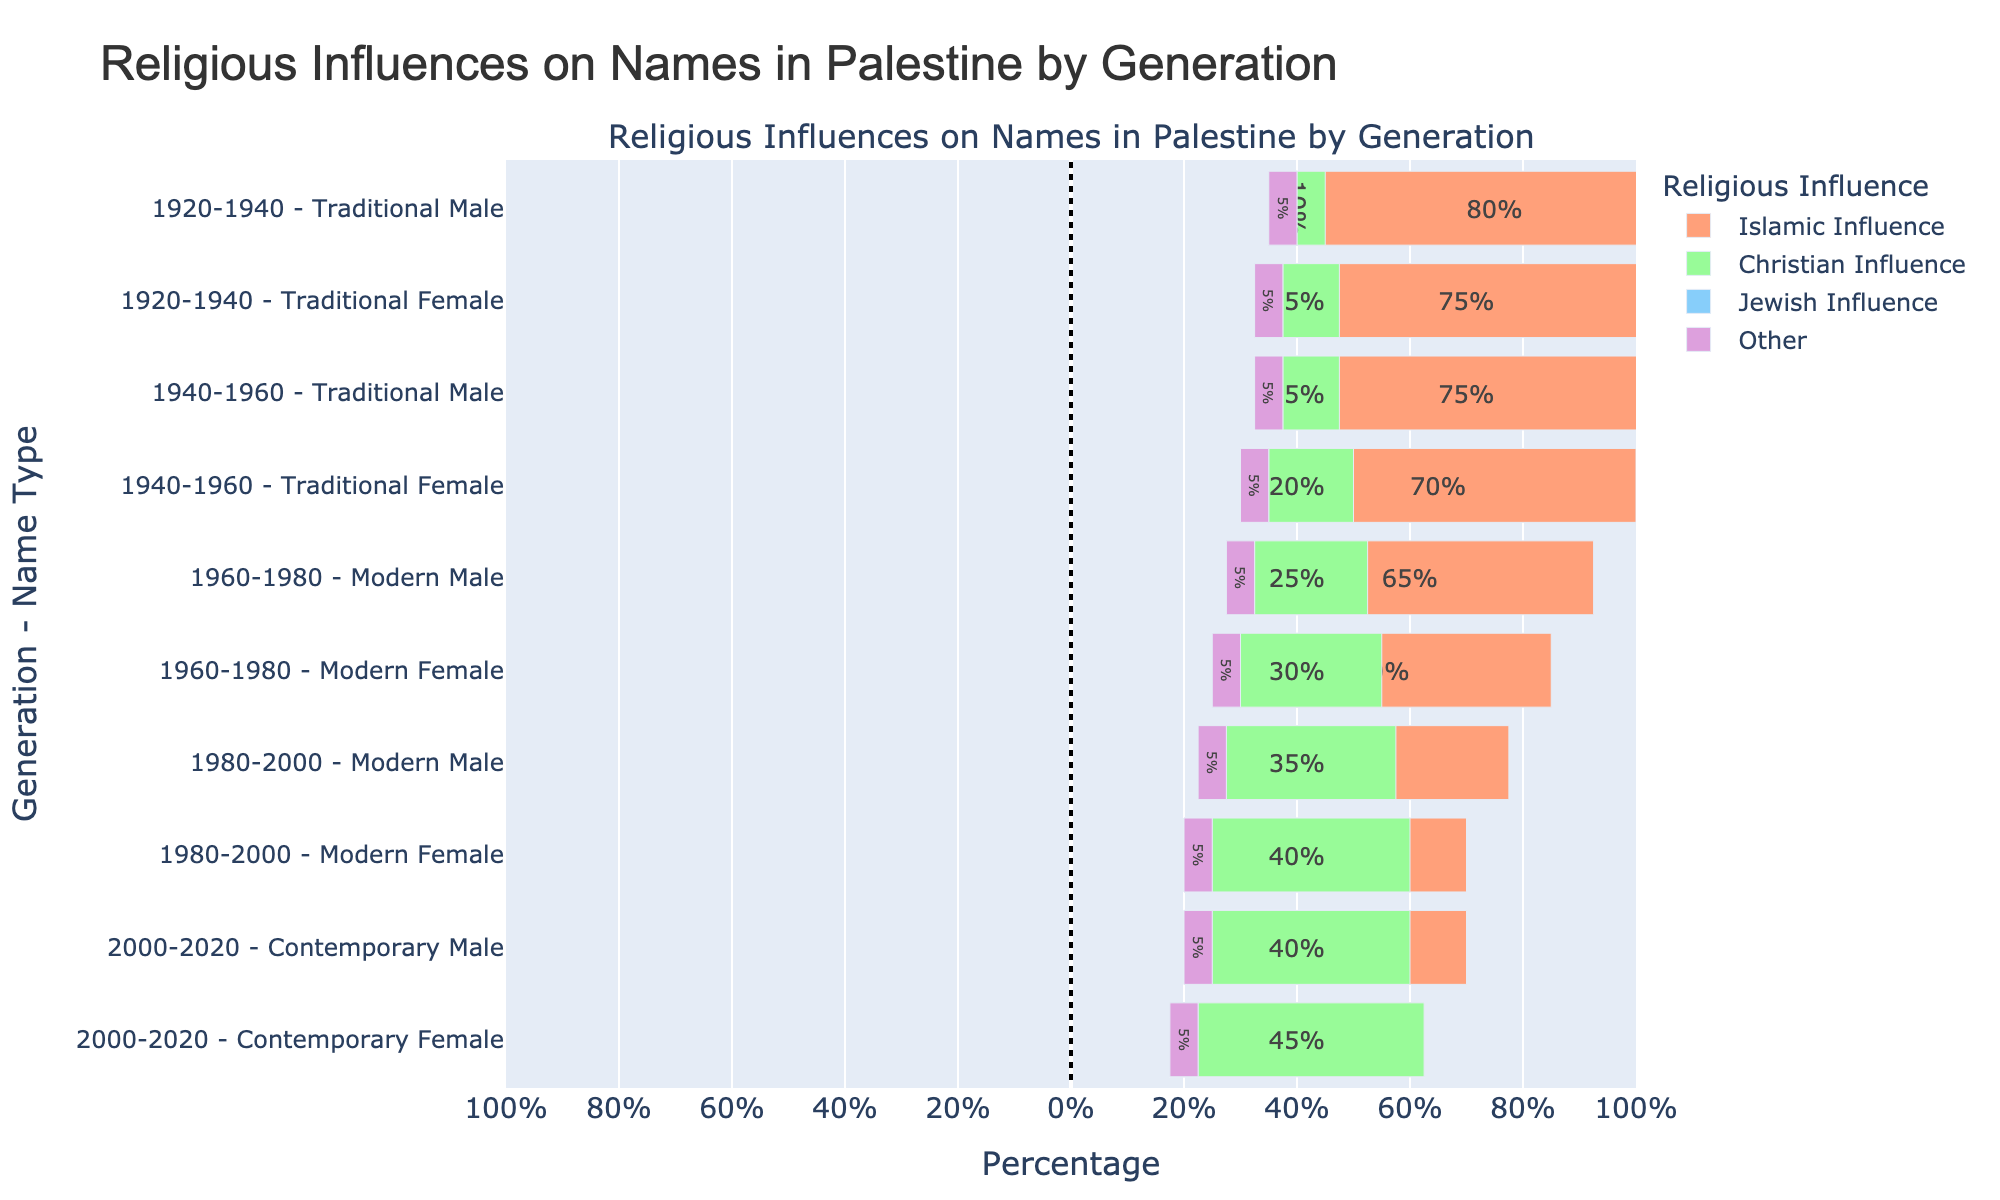What generation has the highest percentage of names with Christian influence? The highest percentage of Christian influence corresponds to the earliest generation, which can be identified from the y-axis and the corresponding bars. For 1920-1940, the Traditional Female names have 15% Christian influence, which decreases in subsequent generations except for a noticeable increase across time.
Answer: 2000-2020 How does the Islamic influence on Contemporary Female names compare to Traditional Male names from 1940-1960? The Islamic influence for Contemporary Female names from 2000-2020 is 45%, while for Traditional Male names from 1940-1960, it's 75%. The comparison shows a decrease over time.
Answer: Decreased Which gender saw a greater reduction in Islamic influence from 1920-2020? To answer this, we compare the Islamic influence on Traditional Male and Traditional Female names in 1920-1940 with that of Contemporary Male and Contemporary Female names in 2000-2020. Traditional Male names started at 80%, reducing to 50%, a decrease of 30%. Traditional Female names started at 75%, decreasing to 45%, a reduction of 30%. Since both reductions are equal, neither saw a greater decrease.
Answer: Equal What is the total percentage of non-Islamic influences (sum of Christian, Jewish, and Other) on Modern Male names in 1960-1980? The percentages of Christian, Jewish, and Other influences on Modern Male names in this generation are 25%, 5%, and 5% respectively. Summing these percentages: 25 + 5 + 5 = 35%.
Answer: 35% Which generation and name type have the least percentage of Jewish influence? By examining the Jewish influence across each generation and name type, we see that the percentage remains constant at 5% across all categories. Hence, no specific generation or name type can be singled out.
Answer: All equal What is the difference in Christian influence between Modern Female and Contemporary Female names? The Christian influence on Modern Female names (1960-1980) is 30%, while for Contemporary Female names (2000-2020) it is 45%. The difference is calculated as 45 - 30 = 15%.
Answer: 15% Which generation of male names displays the most balanced distribution of influences? By looking at the lengths of the bars in the figure, Contemporary Male names (2000-2020) seem to have the most balanced distribution, with 50% Islamic, 40% Christian, 5% Jewish, and 5% Other influences.
Answer: 2000-2020 How did the Islamic influence on Female names change from the 1920-1940 generation to the 1980-2000 generation? The Islamic influence on Female names was 75% in the 1920-1940 generation and reduced to 50% in the 1980-2000 generation. The change is calculated as 50 - 75 = -25%, representing a decrease.
Answer: Decreased by 25% For which generation and gender is the 'Other' influence highest? The 'Other' influence percentage remains constant at 5% across all generations and genders, indicating no variability regarding the 'Other' category.
Answer: All equal 